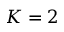<formula> <loc_0><loc_0><loc_500><loc_500>K = 2</formula> 